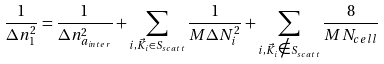<formula> <loc_0><loc_0><loc_500><loc_500>\frac { 1 } { \Delta n _ { 1 } ^ { 2 } } = \frac { 1 } { \Delta n _ { a _ { i n t e r } } ^ { 2 } } + \sum _ { i , \vec { K } _ { i } \in S _ { s c a t t } } \frac { 1 } { M \Delta N _ { i } ^ { 2 } } + \sum _ { i , \vec { K } _ { i } \notin S _ { s c a t t } } \frac { 8 } { M N _ { c e l l } }</formula> 